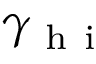<formula> <loc_0><loc_0><loc_500><loc_500>\gamma _ { h i }</formula> 